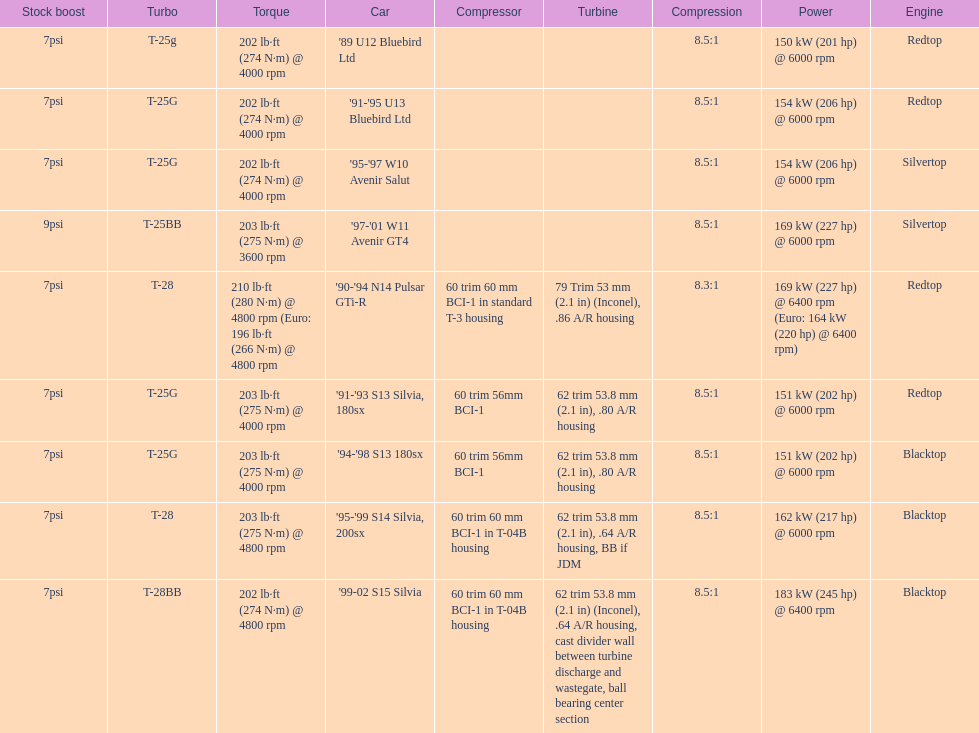Which car is the only one with more than 230 hp? '99-02 S15 Silvia. 